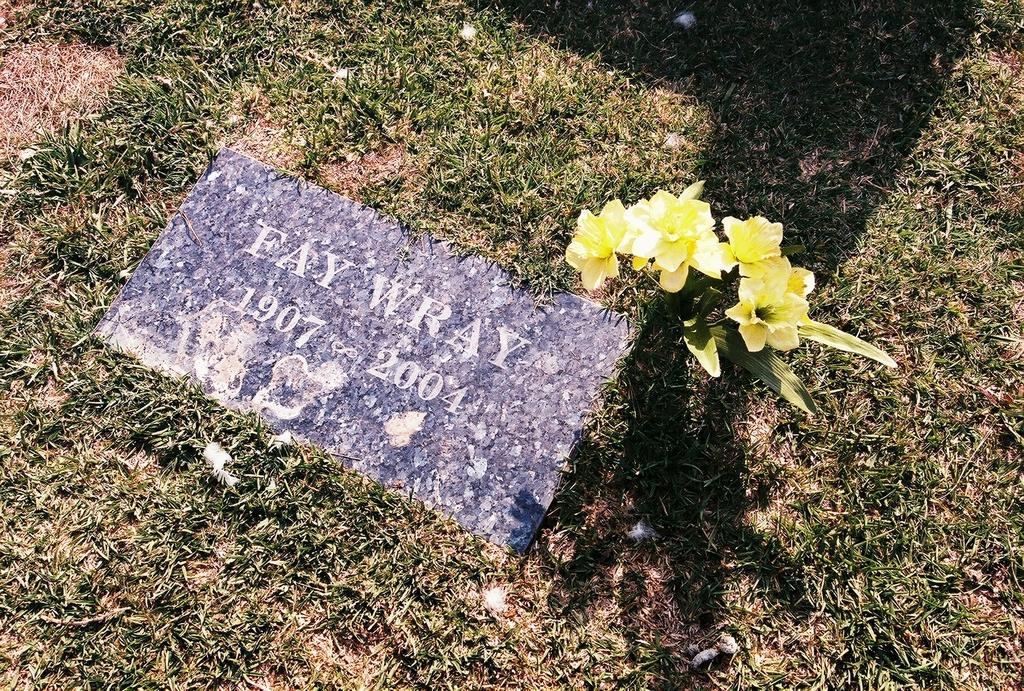Can you describe this image briefly? In this image in the center there is one tile, and on the tile there is some text and there are some flowers. In the background there is grass and some scrap. 